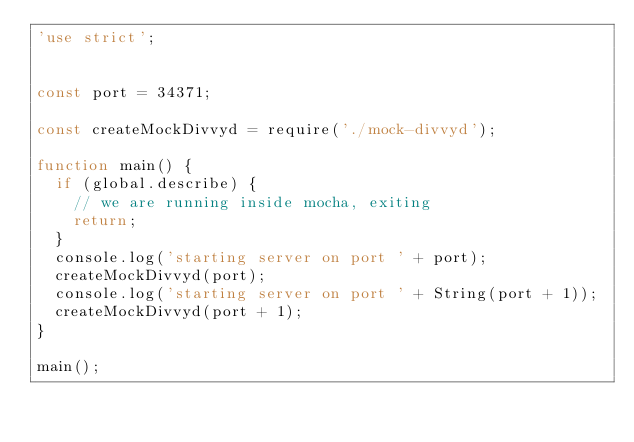<code> <loc_0><loc_0><loc_500><loc_500><_JavaScript_>'use strict';


const port = 34371;

const createMockDivvyd = require('./mock-divvyd');

function main() {
  if (global.describe) {
    // we are running inside mocha, exiting
    return;
  }
  console.log('starting server on port ' + port);
  createMockDivvyd(port);
  console.log('starting server on port ' + String(port + 1));
  createMockDivvyd(port + 1);
}

main();
</code> 